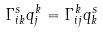Convert formula to latex. <formula><loc_0><loc_0><loc_500><loc_500>\Gamma _ { i k } ^ { s } q ^ { k } _ { j } = \Gamma _ { i j } ^ { k } q ^ { s } _ { k }</formula> 